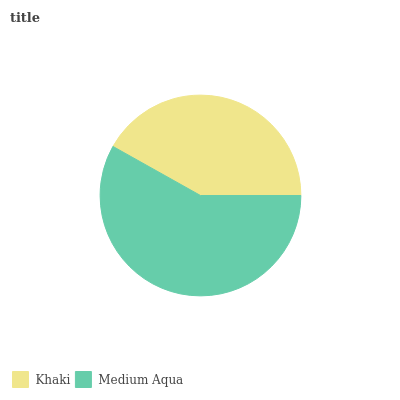Is Khaki the minimum?
Answer yes or no. Yes. Is Medium Aqua the maximum?
Answer yes or no. Yes. Is Medium Aqua the minimum?
Answer yes or no. No. Is Medium Aqua greater than Khaki?
Answer yes or no. Yes. Is Khaki less than Medium Aqua?
Answer yes or no. Yes. Is Khaki greater than Medium Aqua?
Answer yes or no. No. Is Medium Aqua less than Khaki?
Answer yes or no. No. Is Medium Aqua the high median?
Answer yes or no. Yes. Is Khaki the low median?
Answer yes or no. Yes. Is Khaki the high median?
Answer yes or no. No. Is Medium Aqua the low median?
Answer yes or no. No. 